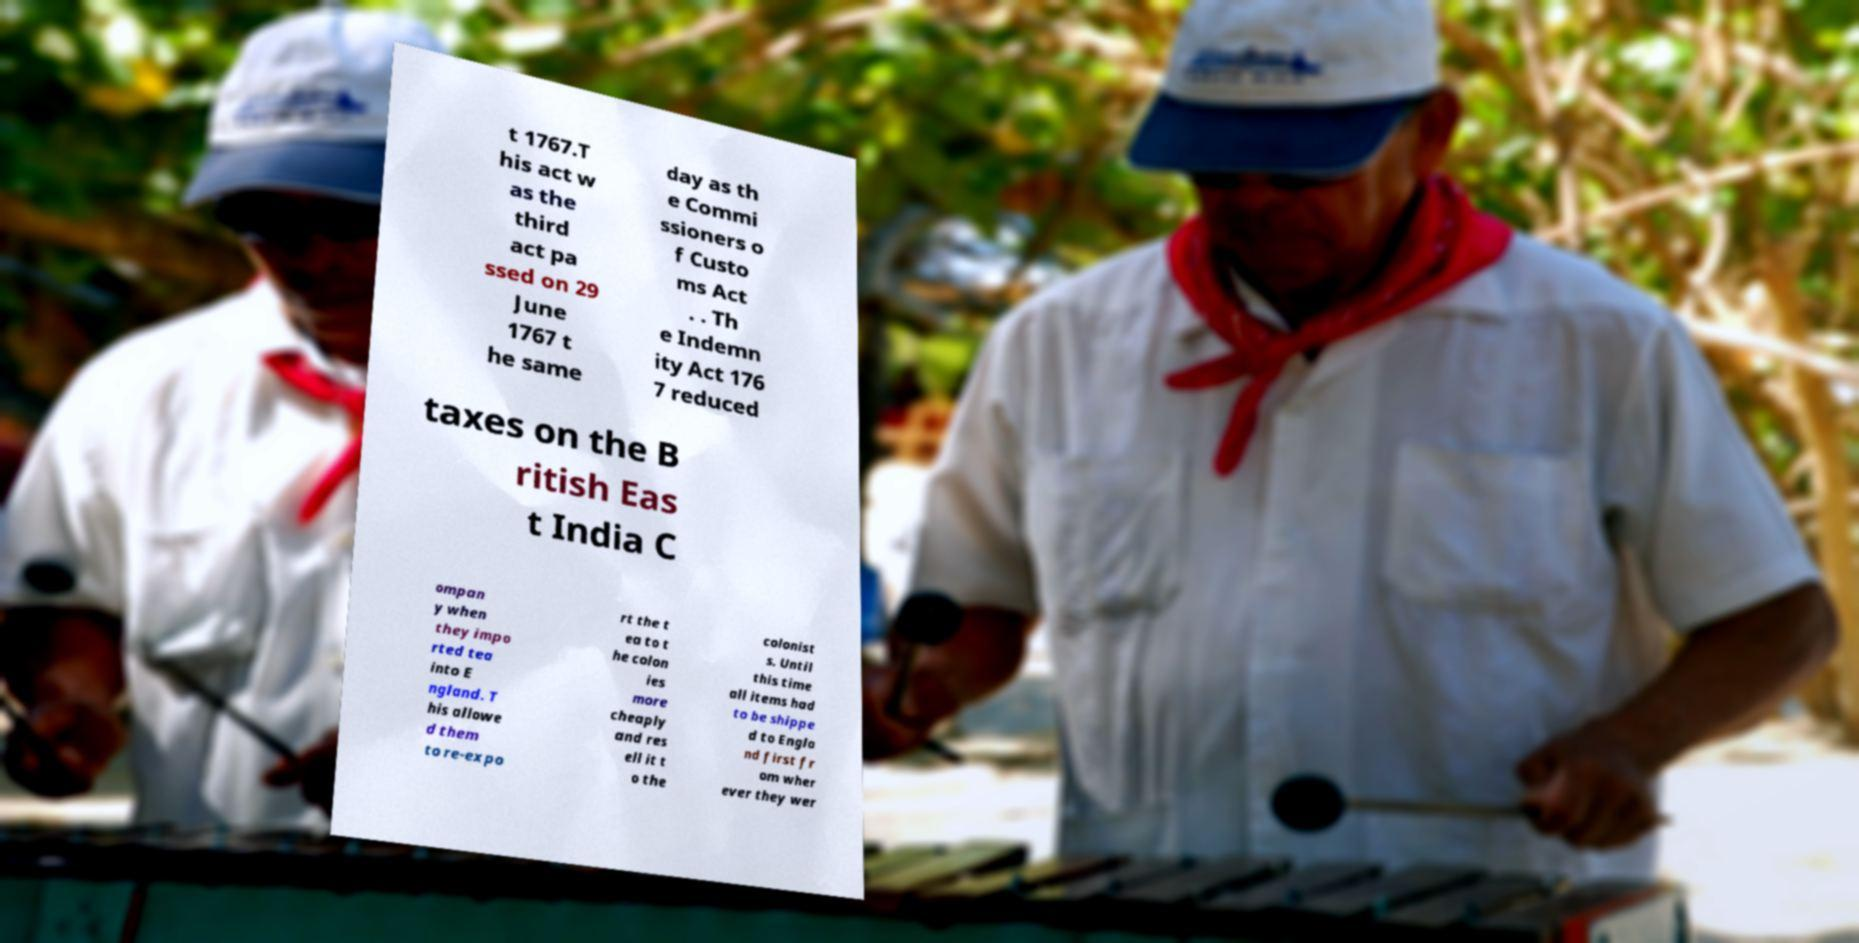Please identify and transcribe the text found in this image. t 1767.T his act w as the third act pa ssed on 29 June 1767 t he same day as th e Commi ssioners o f Custo ms Act . . Th e Indemn ity Act 176 7 reduced taxes on the B ritish Eas t India C ompan y when they impo rted tea into E ngland. T his allowe d them to re-expo rt the t ea to t he colon ies more cheaply and res ell it t o the colonist s. Until this time all items had to be shippe d to Engla nd first fr om wher ever they wer 